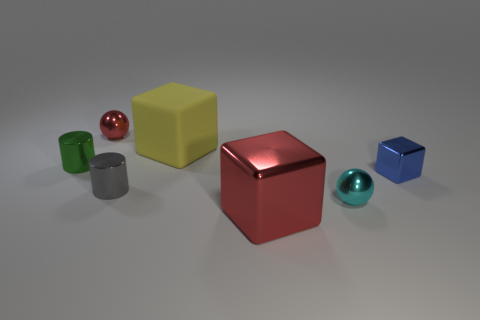What shape is the red metallic thing behind the small shiny cylinder on the left side of the small sphere that is to the left of the tiny cyan shiny thing?
Provide a short and direct response. Sphere. Are there the same number of tiny green cylinders that are right of the green cylinder and tiny metallic objects in front of the cyan shiny ball?
Offer a terse response. Yes. What is the color of the shiny cube that is the same size as the yellow matte block?
Your answer should be compact. Red. What number of large things are either purple blocks or red shiny objects?
Offer a very short reply. 1. What is the tiny thing that is behind the blue block and on the right side of the small green metallic thing made of?
Make the answer very short. Metal. Is the shape of the red thing that is in front of the yellow matte object the same as the metallic thing that is behind the rubber block?
Make the answer very short. No. The shiny object that is the same color as the large metal cube is what shape?
Provide a short and direct response. Sphere. What number of things are red shiny objects that are behind the tiny green cylinder or small cyan objects?
Offer a very short reply. 2. Do the yellow object and the gray cylinder have the same size?
Your response must be concise. No. What is the color of the object in front of the cyan shiny sphere?
Provide a short and direct response. Red. 